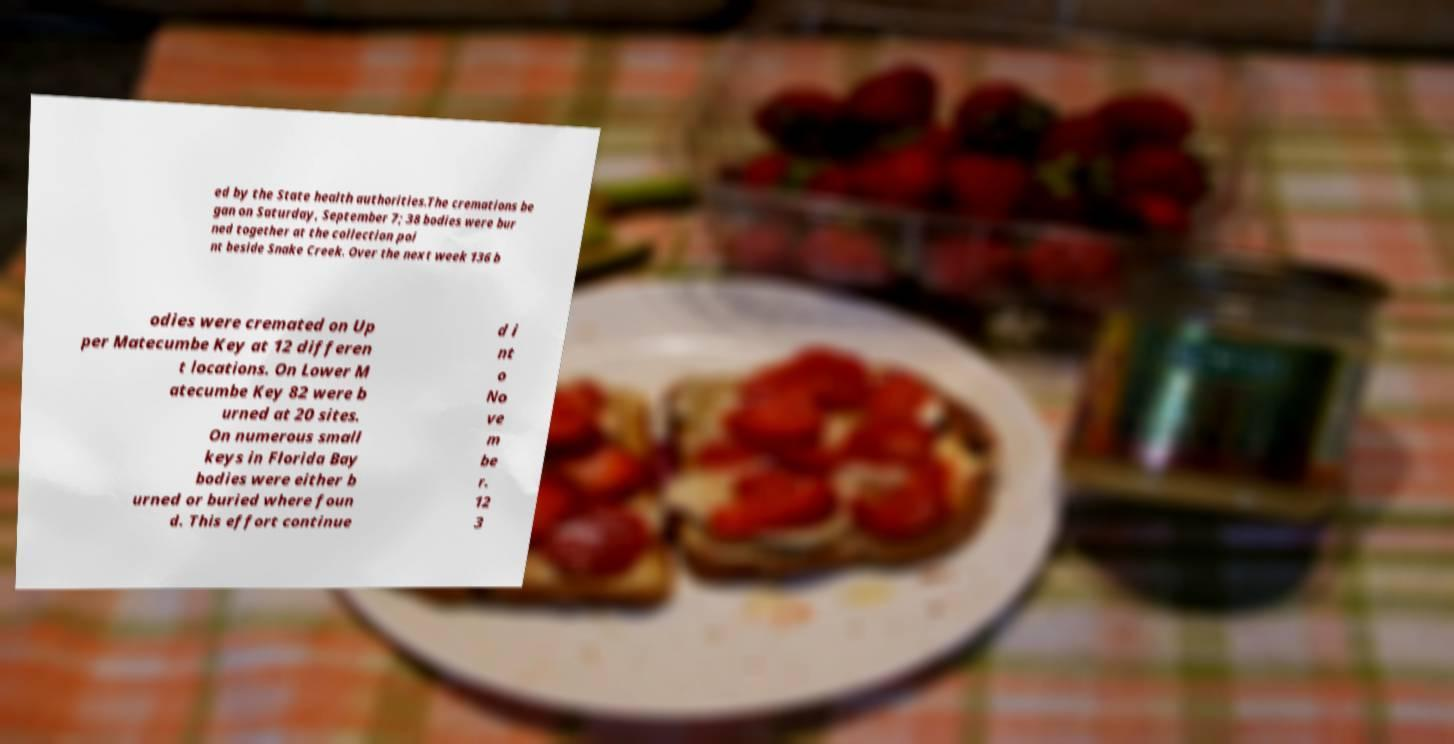Please read and relay the text visible in this image. What does it say? ed by the State health authorities.The cremations be gan on Saturday, September 7; 38 bodies were bur ned together at the collection poi nt beside Snake Creek. Over the next week 136 b odies were cremated on Up per Matecumbe Key at 12 differen t locations. On Lower M atecumbe Key 82 were b urned at 20 sites. On numerous small keys in Florida Bay bodies were either b urned or buried where foun d. This effort continue d i nt o No ve m be r. 12 3 